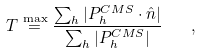Convert formula to latex. <formula><loc_0><loc_0><loc_500><loc_500>T \stackrel { \max } { = } \frac { \sum _ { h } | P ^ { C M S } _ { h } \cdot \hat { n } | } { \sum _ { h } | P ^ { C M S } _ { h } | } \quad ,</formula> 